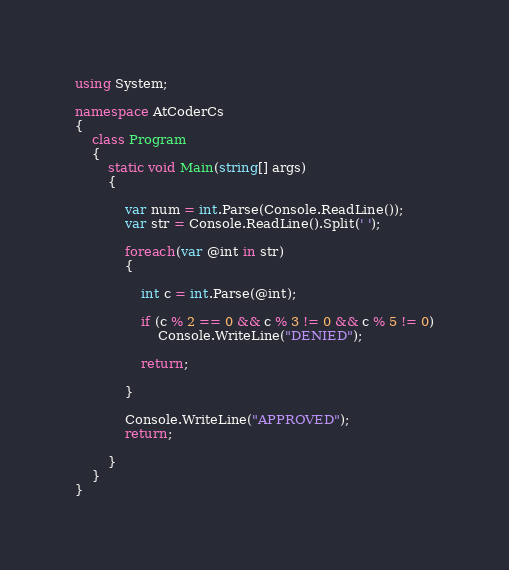<code> <loc_0><loc_0><loc_500><loc_500><_C#_>using System;

namespace AtCoderCs
{
    class Program
    {
        static void Main(string[] args)
        {

            var num = int.Parse(Console.ReadLine());
            var str = Console.ReadLine().Split(' ');

            foreach(var @int in str)
            {

                int c = int.Parse(@int);

                if (c % 2 == 0 && c % 3 != 0 && c % 5 != 0)
                    Console.WriteLine("DENIED");

                return;

            }

            Console.WriteLine("APPROVED");
            return;

        }
    }
}</code> 